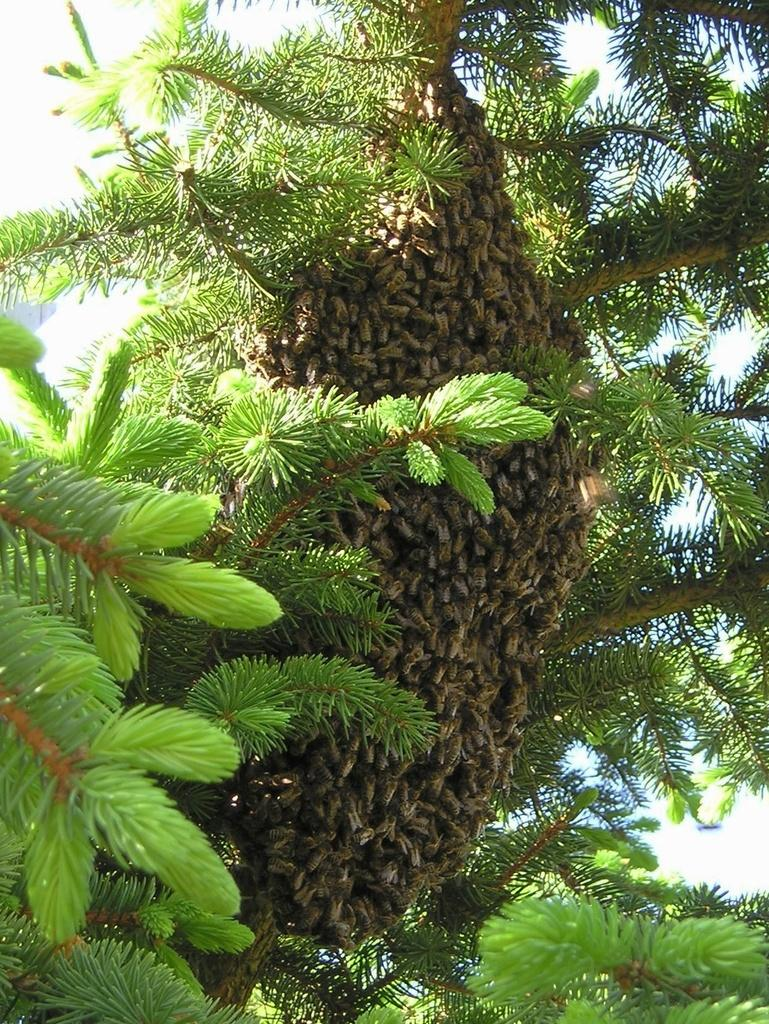What type of vegetation can be seen in the image? There are trees in the image. What creatures are present on the trees? There are honey bees on the trees. What can be seen in the background of the image? Clouds and the sky are visible in the background of the image. How many errors can be found in the image? There are no errors present in the image; it is a photograph of trees and honey bees. What is the distance between the trees and the clouds in the image? The distance between the trees and the clouds cannot be determined from the image, as it is a two-dimensional representation. 